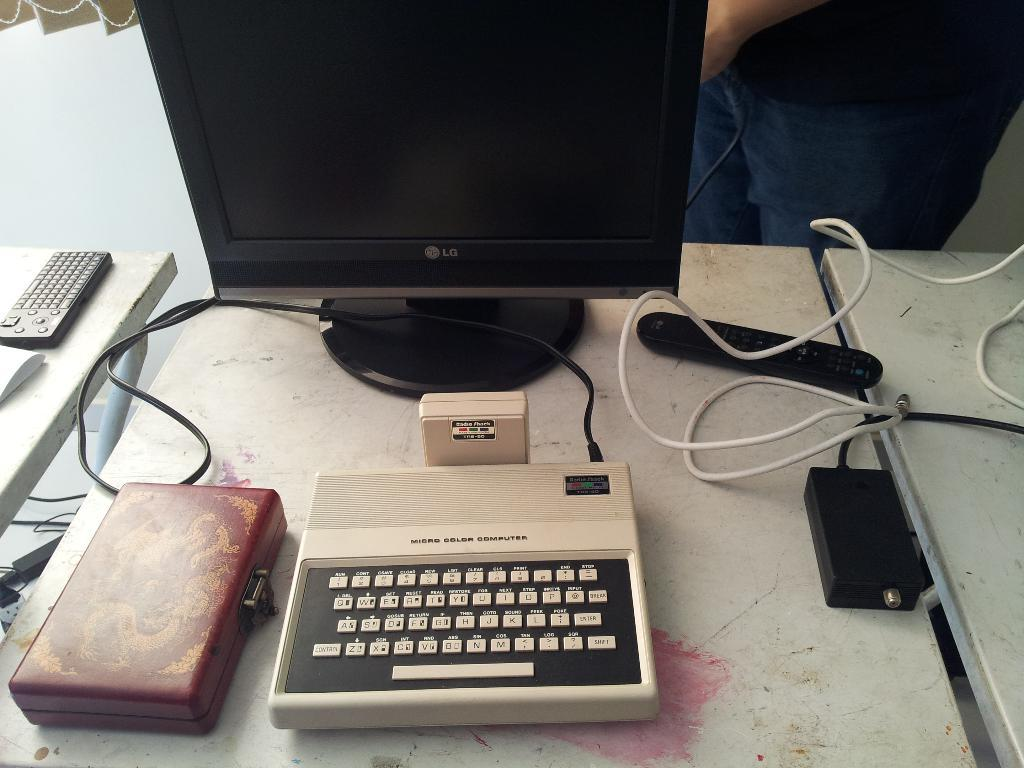<image>
Write a terse but informative summary of the picture. A micro color computer is hooked up to an LG monitor. 